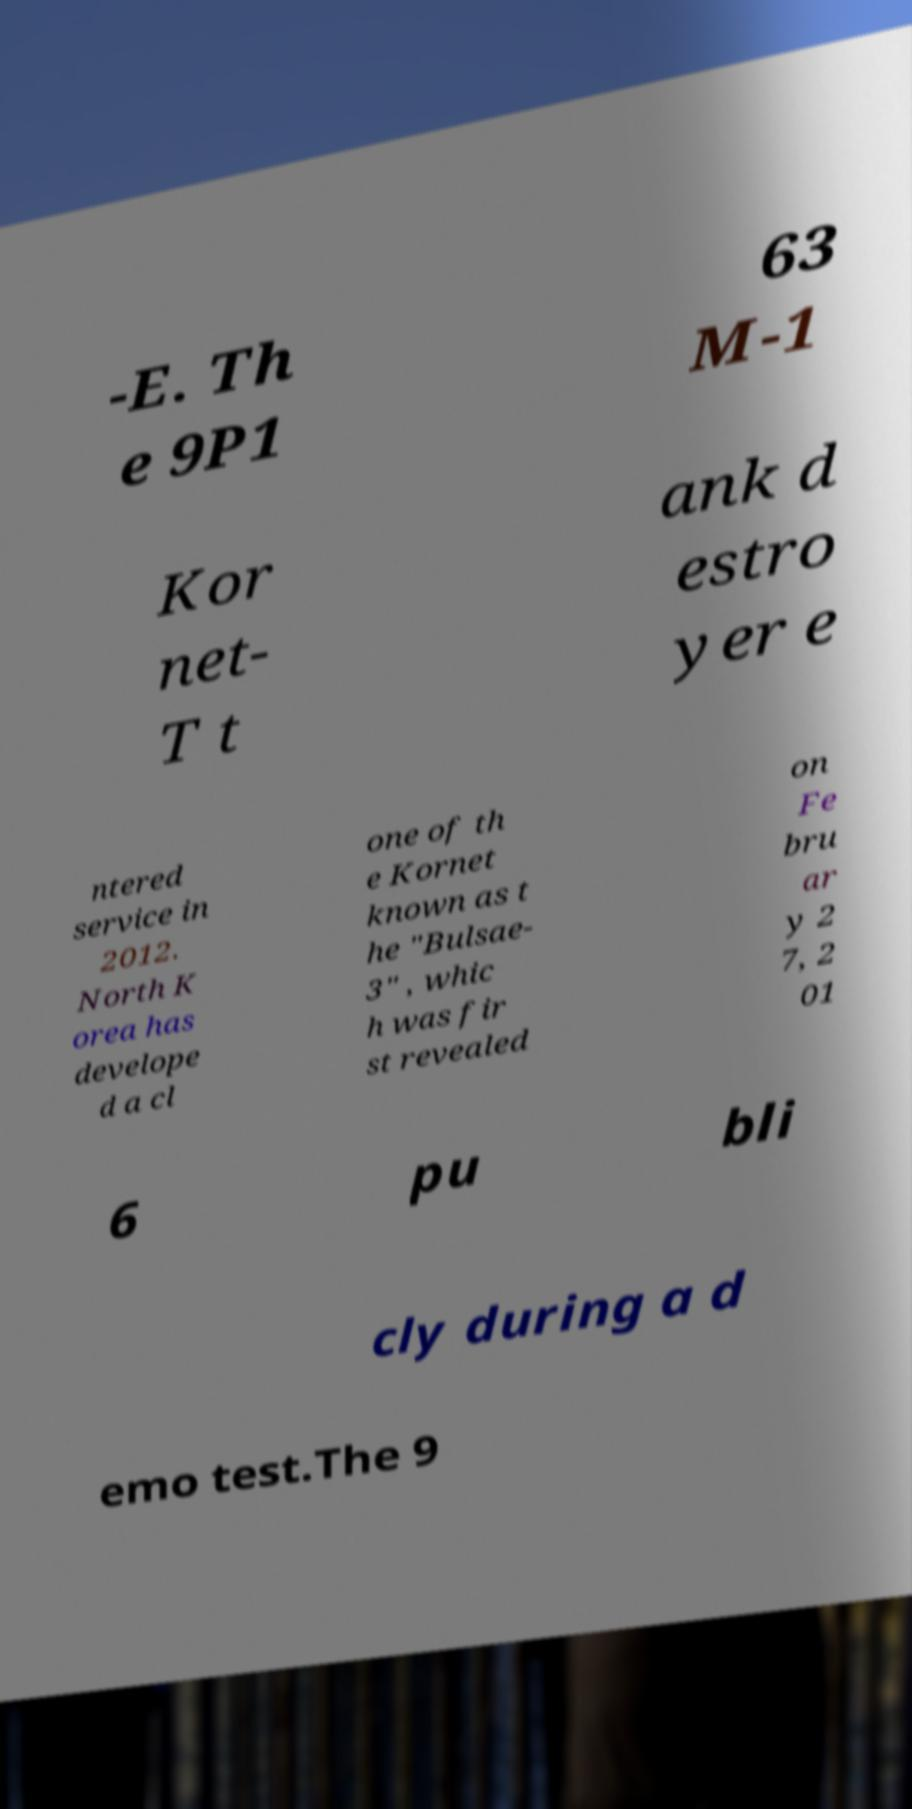For documentation purposes, I need the text within this image transcribed. Could you provide that? -E. Th e 9P1 63 M-1 Kor net- T t ank d estro yer e ntered service in 2012. North K orea has develope d a cl one of th e Kornet known as t he "Bulsae- 3" , whic h was fir st revealed on Fe bru ar y 2 7, 2 01 6 pu bli cly during a d emo test.The 9 